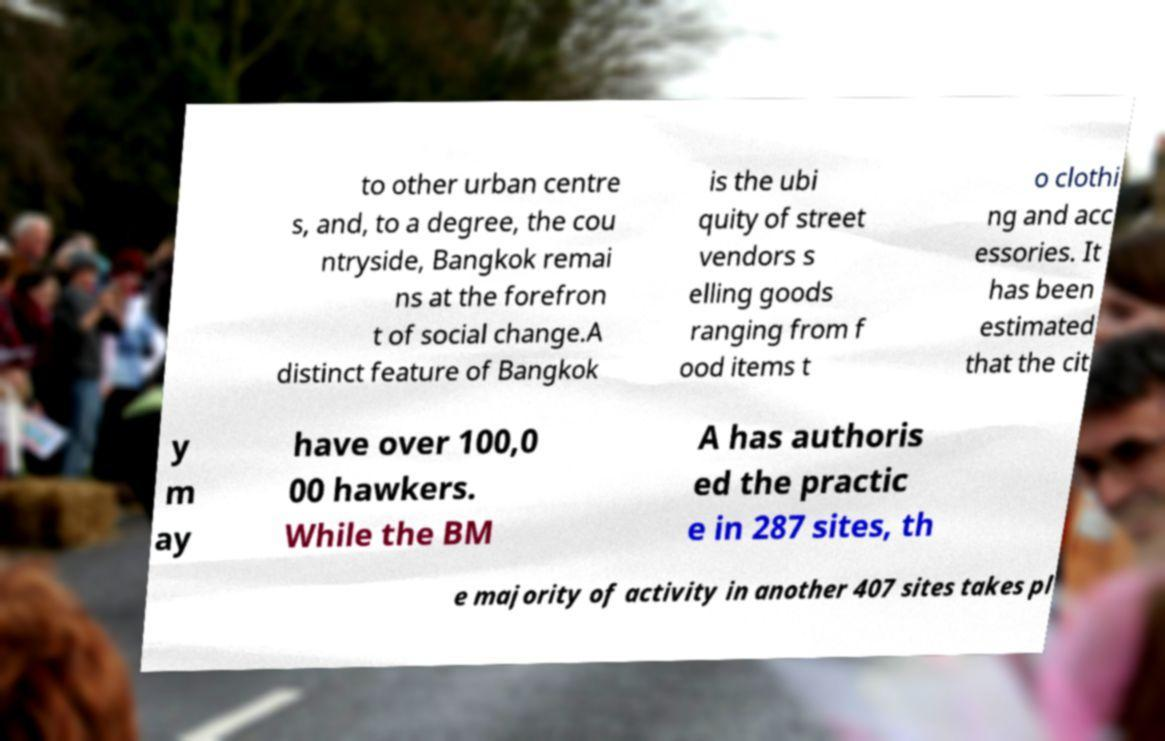Please identify and transcribe the text found in this image. to other urban centre s, and, to a degree, the cou ntryside, Bangkok remai ns at the forefron t of social change.A distinct feature of Bangkok is the ubi quity of street vendors s elling goods ranging from f ood items t o clothi ng and acc essories. It has been estimated that the cit y m ay have over 100,0 00 hawkers. While the BM A has authoris ed the practic e in 287 sites, th e majority of activity in another 407 sites takes pl 